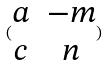<formula> <loc_0><loc_0><loc_500><loc_500>( \begin{matrix} a & - m \\ c & n \end{matrix} )</formula> 